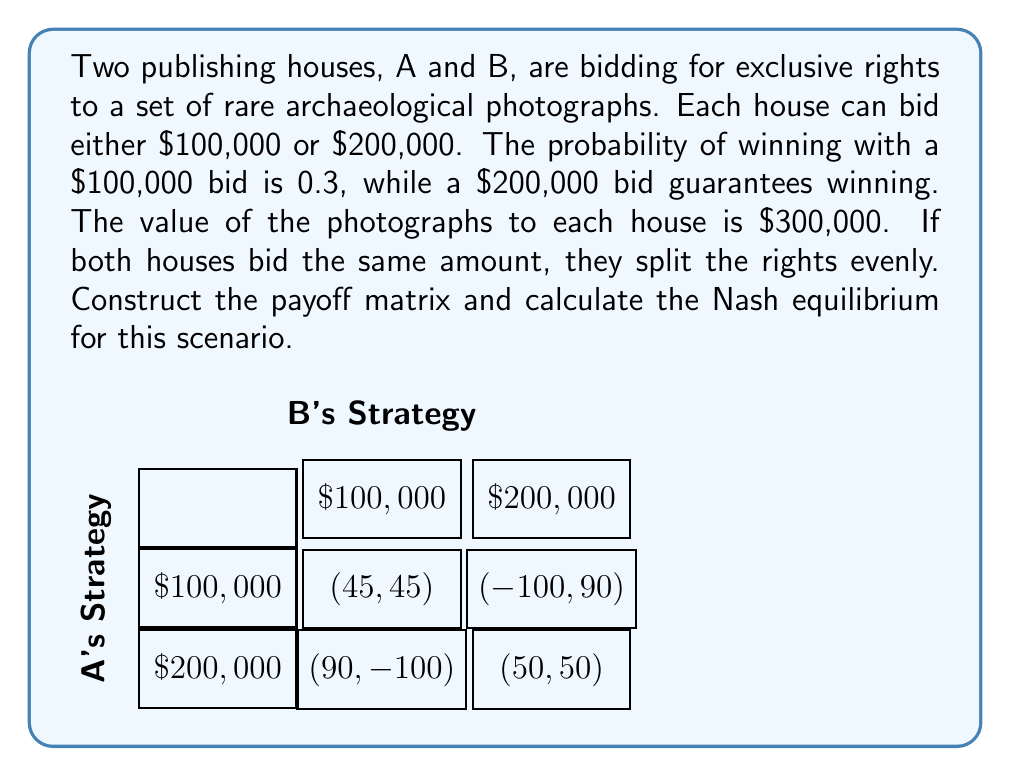Give your solution to this math problem. To solve this problem, we'll follow these steps:

1) Construct the payoff matrix:
   Let's calculate the payoffs for each scenario (in thousands of dollars):
   
   a) Both bid $100,000: 0.5 * 0.3 * 300 - 100 = 45 for each
   b) One bids $100,000, other $200,000: 
      - For $100,000 bidder: 0 * 300 - 100 = -100
      - For $200,000 bidder: 1 * 300 - 200 = 100
   c) Both bid $200,000: 0.5 * 300 - 200 = 50 for each

2) Analyze for dominant strategies:
   Neither player has a dominant strategy.

3) Check for pure strategy Nash equilibrium:
   There is no pure strategy Nash equilibrium as each player wants to do the opposite of their opponent.

4) Calculate mixed strategy Nash equilibrium:
   Let $p$ be the probability of A bidding $100,000, and $q$ be the probability of B bidding $100,000.

   For A to be indifferent:
   $$45q + (-100)(1-q) = 90q + 50(1-q)$$
   $$145q - 100 = 40q + 50$$
   $$105q = 150$$
   $$q = \frac{10}{7} \approx 1.43$$

   Since probabilities can't exceed 1, this means B always bids $200,000.

   For B to be indifferent:
   $$45p + (-100)(1-p) = 90p + 50(1-p)$$
   $$145p - 100 = 40p + 50$$
   $$105p = 150$$
   $$p = \frac{10}{7} \approx 1.43$$

   Again, this exceeds 1, so A always bids $200,000.

5) Conclude:
   The Nash equilibrium is for both players to always bid $200,000.
Answer: Both publishing houses always bid $200,000. 